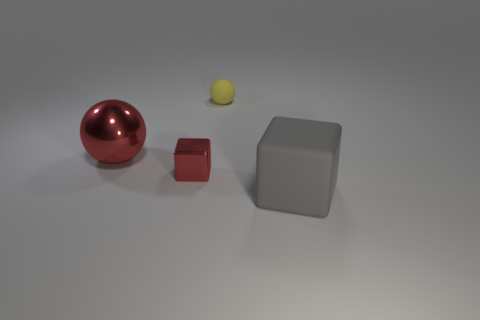Add 1 red cubes. How many objects exist? 5 Subtract all gray blocks. How many blocks are left? 1 Subtract 1 cubes. How many cubes are left? 1 Subtract all cyan blocks. How many purple balls are left? 0 Add 4 small objects. How many small objects exist? 6 Subtract 0 cyan spheres. How many objects are left? 4 Subtract all gray blocks. Subtract all yellow spheres. How many blocks are left? 1 Subtract all rubber cubes. Subtract all tiny spheres. How many objects are left? 2 Add 4 yellow spheres. How many yellow spheres are left? 5 